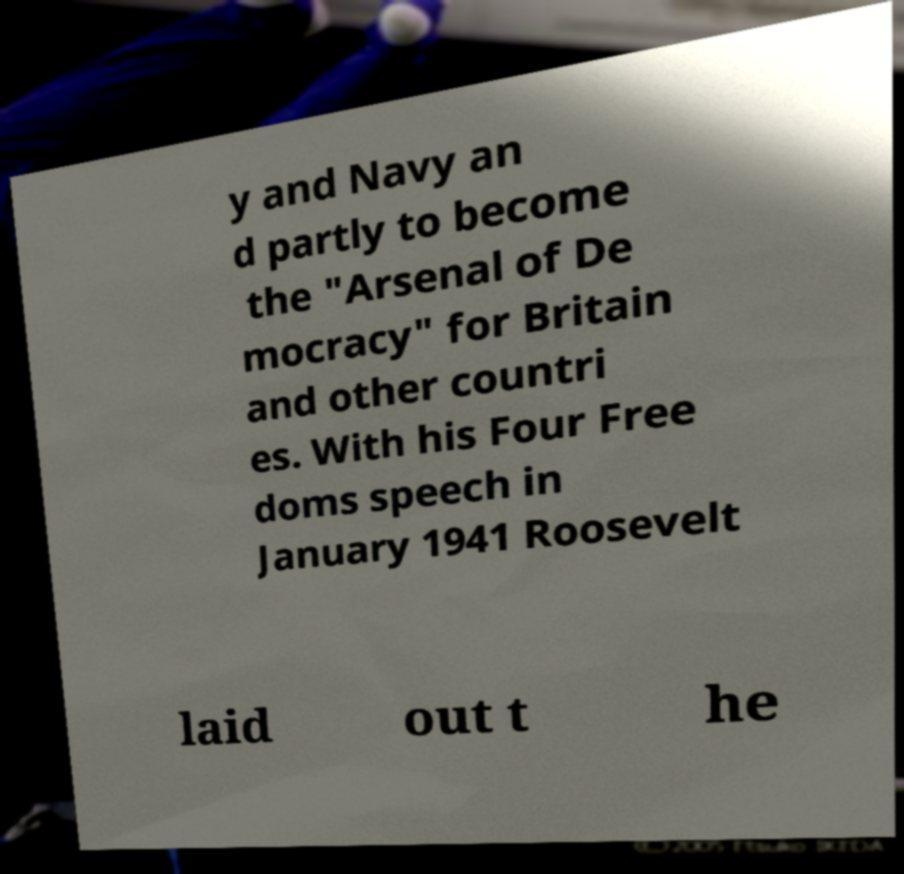Please read and relay the text visible in this image. What does it say? y and Navy an d partly to become the "Arsenal of De mocracy" for Britain and other countri es. With his Four Free doms speech in January 1941 Roosevelt laid out t he 